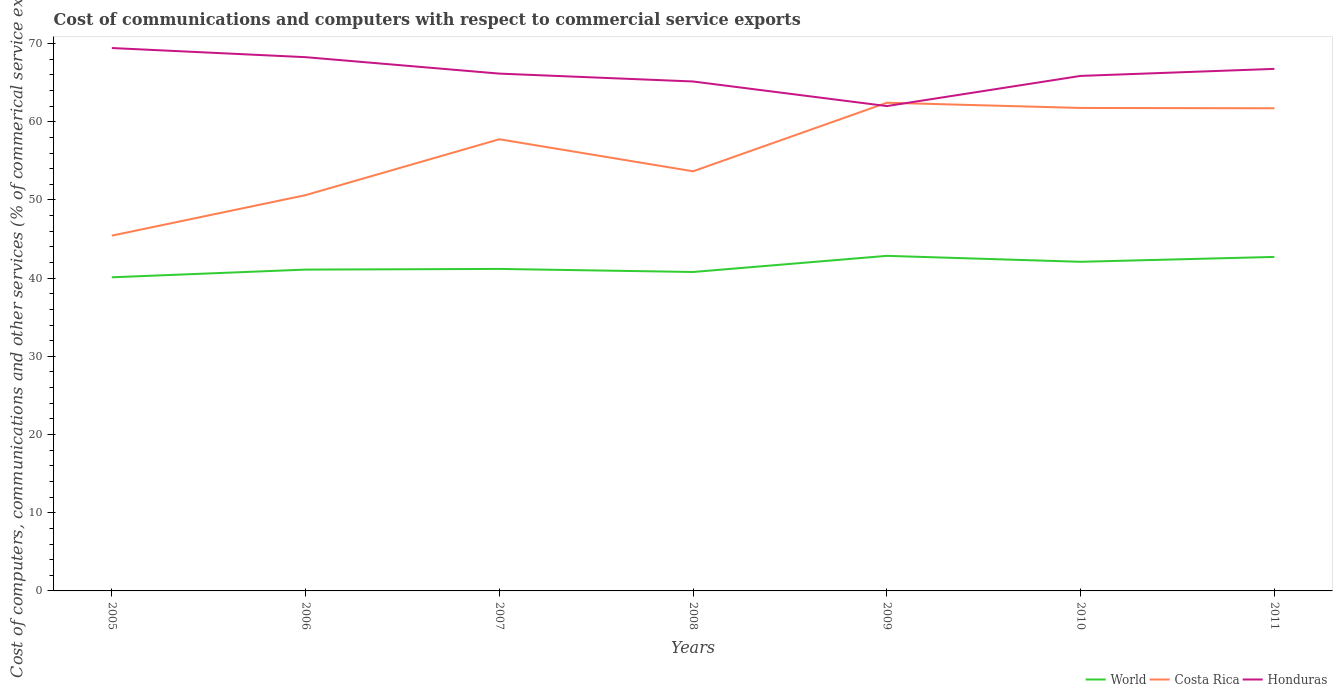Is the number of lines equal to the number of legend labels?
Offer a terse response. Yes. Across all years, what is the maximum cost of communications and computers in Costa Rica?
Keep it short and to the point. 45.44. In which year was the cost of communications and computers in Costa Rica maximum?
Provide a short and direct response. 2005. What is the total cost of communications and computers in Costa Rica in the graph?
Ensure brevity in your answer.  0.71. What is the difference between the highest and the second highest cost of communications and computers in Honduras?
Provide a succinct answer. 7.42. How many years are there in the graph?
Your answer should be very brief. 7. What is the difference between two consecutive major ticks on the Y-axis?
Provide a succinct answer. 10. Does the graph contain grids?
Provide a succinct answer. No. Where does the legend appear in the graph?
Provide a succinct answer. Bottom right. How are the legend labels stacked?
Offer a very short reply. Horizontal. What is the title of the graph?
Make the answer very short. Cost of communications and computers with respect to commercial service exports. Does "Lebanon" appear as one of the legend labels in the graph?
Your answer should be compact. No. What is the label or title of the X-axis?
Provide a succinct answer. Years. What is the label or title of the Y-axis?
Offer a very short reply. Cost of computers, communications and other services (% of commerical service exports). What is the Cost of computers, communications and other services (% of commerical service exports) in World in 2005?
Your response must be concise. 40.11. What is the Cost of computers, communications and other services (% of commerical service exports) of Costa Rica in 2005?
Offer a terse response. 45.44. What is the Cost of computers, communications and other services (% of commerical service exports) of Honduras in 2005?
Your response must be concise. 69.43. What is the Cost of computers, communications and other services (% of commerical service exports) of World in 2006?
Provide a short and direct response. 41.09. What is the Cost of computers, communications and other services (% of commerical service exports) in Costa Rica in 2006?
Your response must be concise. 50.61. What is the Cost of computers, communications and other services (% of commerical service exports) in Honduras in 2006?
Offer a terse response. 68.26. What is the Cost of computers, communications and other services (% of commerical service exports) in World in 2007?
Offer a terse response. 41.18. What is the Cost of computers, communications and other services (% of commerical service exports) of Costa Rica in 2007?
Make the answer very short. 57.76. What is the Cost of computers, communications and other services (% of commerical service exports) of Honduras in 2007?
Your answer should be compact. 66.16. What is the Cost of computers, communications and other services (% of commerical service exports) in World in 2008?
Offer a very short reply. 40.79. What is the Cost of computers, communications and other services (% of commerical service exports) of Costa Rica in 2008?
Your answer should be compact. 53.66. What is the Cost of computers, communications and other services (% of commerical service exports) in Honduras in 2008?
Your answer should be very brief. 65.15. What is the Cost of computers, communications and other services (% of commerical service exports) of World in 2009?
Offer a very short reply. 42.85. What is the Cost of computers, communications and other services (% of commerical service exports) of Costa Rica in 2009?
Provide a succinct answer. 62.43. What is the Cost of computers, communications and other services (% of commerical service exports) of Honduras in 2009?
Offer a terse response. 62. What is the Cost of computers, communications and other services (% of commerical service exports) of World in 2010?
Your answer should be compact. 42.09. What is the Cost of computers, communications and other services (% of commerical service exports) in Costa Rica in 2010?
Offer a terse response. 61.76. What is the Cost of computers, communications and other services (% of commerical service exports) of Honduras in 2010?
Your answer should be very brief. 65.86. What is the Cost of computers, communications and other services (% of commerical service exports) of World in 2011?
Provide a short and direct response. 42.71. What is the Cost of computers, communications and other services (% of commerical service exports) in Costa Rica in 2011?
Your response must be concise. 61.72. What is the Cost of computers, communications and other services (% of commerical service exports) of Honduras in 2011?
Provide a short and direct response. 66.76. Across all years, what is the maximum Cost of computers, communications and other services (% of commerical service exports) of World?
Keep it short and to the point. 42.85. Across all years, what is the maximum Cost of computers, communications and other services (% of commerical service exports) of Costa Rica?
Offer a very short reply. 62.43. Across all years, what is the maximum Cost of computers, communications and other services (% of commerical service exports) in Honduras?
Provide a succinct answer. 69.43. Across all years, what is the minimum Cost of computers, communications and other services (% of commerical service exports) in World?
Your answer should be compact. 40.11. Across all years, what is the minimum Cost of computers, communications and other services (% of commerical service exports) of Costa Rica?
Offer a terse response. 45.44. Across all years, what is the minimum Cost of computers, communications and other services (% of commerical service exports) of Honduras?
Your answer should be very brief. 62. What is the total Cost of computers, communications and other services (% of commerical service exports) in World in the graph?
Keep it short and to the point. 290.82. What is the total Cost of computers, communications and other services (% of commerical service exports) of Costa Rica in the graph?
Provide a succinct answer. 393.39. What is the total Cost of computers, communications and other services (% of commerical service exports) of Honduras in the graph?
Offer a very short reply. 463.62. What is the difference between the Cost of computers, communications and other services (% of commerical service exports) in World in 2005 and that in 2006?
Your response must be concise. -0.98. What is the difference between the Cost of computers, communications and other services (% of commerical service exports) of Costa Rica in 2005 and that in 2006?
Ensure brevity in your answer.  -5.18. What is the difference between the Cost of computers, communications and other services (% of commerical service exports) in Honduras in 2005 and that in 2006?
Your answer should be very brief. 1.17. What is the difference between the Cost of computers, communications and other services (% of commerical service exports) of World in 2005 and that in 2007?
Offer a very short reply. -1.07. What is the difference between the Cost of computers, communications and other services (% of commerical service exports) in Costa Rica in 2005 and that in 2007?
Provide a succinct answer. -12.32. What is the difference between the Cost of computers, communications and other services (% of commerical service exports) in Honduras in 2005 and that in 2007?
Ensure brevity in your answer.  3.27. What is the difference between the Cost of computers, communications and other services (% of commerical service exports) of World in 2005 and that in 2008?
Your answer should be very brief. -0.68. What is the difference between the Cost of computers, communications and other services (% of commerical service exports) in Costa Rica in 2005 and that in 2008?
Make the answer very short. -8.23. What is the difference between the Cost of computers, communications and other services (% of commerical service exports) in Honduras in 2005 and that in 2008?
Your answer should be compact. 4.28. What is the difference between the Cost of computers, communications and other services (% of commerical service exports) in World in 2005 and that in 2009?
Your response must be concise. -2.74. What is the difference between the Cost of computers, communications and other services (% of commerical service exports) in Costa Rica in 2005 and that in 2009?
Your answer should be very brief. -16.99. What is the difference between the Cost of computers, communications and other services (% of commerical service exports) of Honduras in 2005 and that in 2009?
Ensure brevity in your answer.  7.42. What is the difference between the Cost of computers, communications and other services (% of commerical service exports) in World in 2005 and that in 2010?
Give a very brief answer. -1.98. What is the difference between the Cost of computers, communications and other services (% of commerical service exports) in Costa Rica in 2005 and that in 2010?
Offer a terse response. -16.33. What is the difference between the Cost of computers, communications and other services (% of commerical service exports) of Honduras in 2005 and that in 2010?
Your answer should be compact. 3.56. What is the difference between the Cost of computers, communications and other services (% of commerical service exports) in World in 2005 and that in 2011?
Provide a short and direct response. -2.61. What is the difference between the Cost of computers, communications and other services (% of commerical service exports) of Costa Rica in 2005 and that in 2011?
Give a very brief answer. -16.29. What is the difference between the Cost of computers, communications and other services (% of commerical service exports) in Honduras in 2005 and that in 2011?
Provide a succinct answer. 2.66. What is the difference between the Cost of computers, communications and other services (% of commerical service exports) in World in 2006 and that in 2007?
Ensure brevity in your answer.  -0.09. What is the difference between the Cost of computers, communications and other services (% of commerical service exports) of Costa Rica in 2006 and that in 2007?
Give a very brief answer. -7.15. What is the difference between the Cost of computers, communications and other services (% of commerical service exports) of Honduras in 2006 and that in 2007?
Provide a short and direct response. 2.1. What is the difference between the Cost of computers, communications and other services (% of commerical service exports) in World in 2006 and that in 2008?
Offer a very short reply. 0.31. What is the difference between the Cost of computers, communications and other services (% of commerical service exports) of Costa Rica in 2006 and that in 2008?
Provide a succinct answer. -3.05. What is the difference between the Cost of computers, communications and other services (% of commerical service exports) of Honduras in 2006 and that in 2008?
Provide a succinct answer. 3.11. What is the difference between the Cost of computers, communications and other services (% of commerical service exports) of World in 2006 and that in 2009?
Your answer should be very brief. -1.76. What is the difference between the Cost of computers, communications and other services (% of commerical service exports) of Costa Rica in 2006 and that in 2009?
Offer a very short reply. -11.82. What is the difference between the Cost of computers, communications and other services (% of commerical service exports) of Honduras in 2006 and that in 2009?
Give a very brief answer. 6.25. What is the difference between the Cost of computers, communications and other services (% of commerical service exports) of World in 2006 and that in 2010?
Make the answer very short. -1. What is the difference between the Cost of computers, communications and other services (% of commerical service exports) in Costa Rica in 2006 and that in 2010?
Give a very brief answer. -11.15. What is the difference between the Cost of computers, communications and other services (% of commerical service exports) in Honduras in 2006 and that in 2010?
Ensure brevity in your answer.  2.4. What is the difference between the Cost of computers, communications and other services (% of commerical service exports) in World in 2006 and that in 2011?
Offer a terse response. -1.62. What is the difference between the Cost of computers, communications and other services (% of commerical service exports) in Costa Rica in 2006 and that in 2011?
Keep it short and to the point. -11.11. What is the difference between the Cost of computers, communications and other services (% of commerical service exports) of Honduras in 2006 and that in 2011?
Ensure brevity in your answer.  1.5. What is the difference between the Cost of computers, communications and other services (% of commerical service exports) in World in 2007 and that in 2008?
Your answer should be very brief. 0.39. What is the difference between the Cost of computers, communications and other services (% of commerical service exports) in Costa Rica in 2007 and that in 2008?
Your answer should be compact. 4.1. What is the difference between the Cost of computers, communications and other services (% of commerical service exports) of World in 2007 and that in 2009?
Offer a terse response. -1.67. What is the difference between the Cost of computers, communications and other services (% of commerical service exports) of Costa Rica in 2007 and that in 2009?
Provide a short and direct response. -4.67. What is the difference between the Cost of computers, communications and other services (% of commerical service exports) in Honduras in 2007 and that in 2009?
Make the answer very short. 4.15. What is the difference between the Cost of computers, communications and other services (% of commerical service exports) in World in 2007 and that in 2010?
Provide a succinct answer. -0.91. What is the difference between the Cost of computers, communications and other services (% of commerical service exports) of Costa Rica in 2007 and that in 2010?
Your answer should be compact. -4. What is the difference between the Cost of computers, communications and other services (% of commerical service exports) of Honduras in 2007 and that in 2010?
Ensure brevity in your answer.  0.29. What is the difference between the Cost of computers, communications and other services (% of commerical service exports) of World in 2007 and that in 2011?
Your answer should be very brief. -1.54. What is the difference between the Cost of computers, communications and other services (% of commerical service exports) in Costa Rica in 2007 and that in 2011?
Provide a short and direct response. -3.96. What is the difference between the Cost of computers, communications and other services (% of commerical service exports) in Honduras in 2007 and that in 2011?
Your answer should be very brief. -0.61. What is the difference between the Cost of computers, communications and other services (% of commerical service exports) in World in 2008 and that in 2009?
Make the answer very short. -2.06. What is the difference between the Cost of computers, communications and other services (% of commerical service exports) in Costa Rica in 2008 and that in 2009?
Ensure brevity in your answer.  -8.77. What is the difference between the Cost of computers, communications and other services (% of commerical service exports) of Honduras in 2008 and that in 2009?
Offer a very short reply. 3.14. What is the difference between the Cost of computers, communications and other services (% of commerical service exports) of World in 2008 and that in 2010?
Provide a short and direct response. -1.3. What is the difference between the Cost of computers, communications and other services (% of commerical service exports) in Costa Rica in 2008 and that in 2010?
Make the answer very short. -8.1. What is the difference between the Cost of computers, communications and other services (% of commerical service exports) of Honduras in 2008 and that in 2010?
Provide a short and direct response. -0.71. What is the difference between the Cost of computers, communications and other services (% of commerical service exports) of World in 2008 and that in 2011?
Your answer should be compact. -1.93. What is the difference between the Cost of computers, communications and other services (% of commerical service exports) in Costa Rica in 2008 and that in 2011?
Provide a short and direct response. -8.06. What is the difference between the Cost of computers, communications and other services (% of commerical service exports) in Honduras in 2008 and that in 2011?
Your response must be concise. -1.61. What is the difference between the Cost of computers, communications and other services (% of commerical service exports) of World in 2009 and that in 2010?
Offer a terse response. 0.76. What is the difference between the Cost of computers, communications and other services (% of commerical service exports) in Costa Rica in 2009 and that in 2010?
Keep it short and to the point. 0.67. What is the difference between the Cost of computers, communications and other services (% of commerical service exports) of Honduras in 2009 and that in 2010?
Keep it short and to the point. -3.86. What is the difference between the Cost of computers, communications and other services (% of commerical service exports) of World in 2009 and that in 2011?
Give a very brief answer. 0.14. What is the difference between the Cost of computers, communications and other services (% of commerical service exports) in Costa Rica in 2009 and that in 2011?
Your answer should be compact. 0.71. What is the difference between the Cost of computers, communications and other services (% of commerical service exports) in Honduras in 2009 and that in 2011?
Make the answer very short. -4.76. What is the difference between the Cost of computers, communications and other services (% of commerical service exports) of World in 2010 and that in 2011?
Provide a short and direct response. -0.62. What is the difference between the Cost of computers, communications and other services (% of commerical service exports) of Costa Rica in 2010 and that in 2011?
Provide a short and direct response. 0.04. What is the difference between the Cost of computers, communications and other services (% of commerical service exports) in Honduras in 2010 and that in 2011?
Ensure brevity in your answer.  -0.9. What is the difference between the Cost of computers, communications and other services (% of commerical service exports) in World in 2005 and the Cost of computers, communications and other services (% of commerical service exports) in Costa Rica in 2006?
Your response must be concise. -10.51. What is the difference between the Cost of computers, communications and other services (% of commerical service exports) in World in 2005 and the Cost of computers, communications and other services (% of commerical service exports) in Honduras in 2006?
Ensure brevity in your answer.  -28.15. What is the difference between the Cost of computers, communications and other services (% of commerical service exports) of Costa Rica in 2005 and the Cost of computers, communications and other services (% of commerical service exports) of Honduras in 2006?
Offer a terse response. -22.82. What is the difference between the Cost of computers, communications and other services (% of commerical service exports) in World in 2005 and the Cost of computers, communications and other services (% of commerical service exports) in Costa Rica in 2007?
Offer a terse response. -17.65. What is the difference between the Cost of computers, communications and other services (% of commerical service exports) in World in 2005 and the Cost of computers, communications and other services (% of commerical service exports) in Honduras in 2007?
Give a very brief answer. -26.05. What is the difference between the Cost of computers, communications and other services (% of commerical service exports) in Costa Rica in 2005 and the Cost of computers, communications and other services (% of commerical service exports) in Honduras in 2007?
Provide a short and direct response. -20.72. What is the difference between the Cost of computers, communications and other services (% of commerical service exports) in World in 2005 and the Cost of computers, communications and other services (% of commerical service exports) in Costa Rica in 2008?
Your response must be concise. -13.56. What is the difference between the Cost of computers, communications and other services (% of commerical service exports) in World in 2005 and the Cost of computers, communications and other services (% of commerical service exports) in Honduras in 2008?
Make the answer very short. -25.04. What is the difference between the Cost of computers, communications and other services (% of commerical service exports) of Costa Rica in 2005 and the Cost of computers, communications and other services (% of commerical service exports) of Honduras in 2008?
Your response must be concise. -19.71. What is the difference between the Cost of computers, communications and other services (% of commerical service exports) of World in 2005 and the Cost of computers, communications and other services (% of commerical service exports) of Costa Rica in 2009?
Offer a very short reply. -22.32. What is the difference between the Cost of computers, communications and other services (% of commerical service exports) in World in 2005 and the Cost of computers, communications and other services (% of commerical service exports) in Honduras in 2009?
Your answer should be very brief. -21.9. What is the difference between the Cost of computers, communications and other services (% of commerical service exports) in Costa Rica in 2005 and the Cost of computers, communications and other services (% of commerical service exports) in Honduras in 2009?
Offer a very short reply. -16.57. What is the difference between the Cost of computers, communications and other services (% of commerical service exports) in World in 2005 and the Cost of computers, communications and other services (% of commerical service exports) in Costa Rica in 2010?
Your answer should be very brief. -21.66. What is the difference between the Cost of computers, communications and other services (% of commerical service exports) of World in 2005 and the Cost of computers, communications and other services (% of commerical service exports) of Honduras in 2010?
Ensure brevity in your answer.  -25.75. What is the difference between the Cost of computers, communications and other services (% of commerical service exports) in Costa Rica in 2005 and the Cost of computers, communications and other services (% of commerical service exports) in Honduras in 2010?
Your answer should be compact. -20.43. What is the difference between the Cost of computers, communications and other services (% of commerical service exports) of World in 2005 and the Cost of computers, communications and other services (% of commerical service exports) of Costa Rica in 2011?
Make the answer very short. -21.61. What is the difference between the Cost of computers, communications and other services (% of commerical service exports) in World in 2005 and the Cost of computers, communications and other services (% of commerical service exports) in Honduras in 2011?
Make the answer very short. -26.65. What is the difference between the Cost of computers, communications and other services (% of commerical service exports) of Costa Rica in 2005 and the Cost of computers, communications and other services (% of commerical service exports) of Honduras in 2011?
Ensure brevity in your answer.  -21.33. What is the difference between the Cost of computers, communications and other services (% of commerical service exports) of World in 2006 and the Cost of computers, communications and other services (% of commerical service exports) of Costa Rica in 2007?
Give a very brief answer. -16.67. What is the difference between the Cost of computers, communications and other services (% of commerical service exports) of World in 2006 and the Cost of computers, communications and other services (% of commerical service exports) of Honduras in 2007?
Your response must be concise. -25.06. What is the difference between the Cost of computers, communications and other services (% of commerical service exports) in Costa Rica in 2006 and the Cost of computers, communications and other services (% of commerical service exports) in Honduras in 2007?
Provide a short and direct response. -15.54. What is the difference between the Cost of computers, communications and other services (% of commerical service exports) of World in 2006 and the Cost of computers, communications and other services (% of commerical service exports) of Costa Rica in 2008?
Your answer should be compact. -12.57. What is the difference between the Cost of computers, communications and other services (% of commerical service exports) of World in 2006 and the Cost of computers, communications and other services (% of commerical service exports) of Honduras in 2008?
Your answer should be very brief. -24.06. What is the difference between the Cost of computers, communications and other services (% of commerical service exports) in Costa Rica in 2006 and the Cost of computers, communications and other services (% of commerical service exports) in Honduras in 2008?
Ensure brevity in your answer.  -14.53. What is the difference between the Cost of computers, communications and other services (% of commerical service exports) in World in 2006 and the Cost of computers, communications and other services (% of commerical service exports) in Costa Rica in 2009?
Provide a succinct answer. -21.34. What is the difference between the Cost of computers, communications and other services (% of commerical service exports) of World in 2006 and the Cost of computers, communications and other services (% of commerical service exports) of Honduras in 2009?
Offer a terse response. -20.91. What is the difference between the Cost of computers, communications and other services (% of commerical service exports) of Costa Rica in 2006 and the Cost of computers, communications and other services (% of commerical service exports) of Honduras in 2009?
Offer a terse response. -11.39. What is the difference between the Cost of computers, communications and other services (% of commerical service exports) in World in 2006 and the Cost of computers, communications and other services (% of commerical service exports) in Costa Rica in 2010?
Offer a very short reply. -20.67. What is the difference between the Cost of computers, communications and other services (% of commerical service exports) in World in 2006 and the Cost of computers, communications and other services (% of commerical service exports) in Honduras in 2010?
Ensure brevity in your answer.  -24.77. What is the difference between the Cost of computers, communications and other services (% of commerical service exports) in Costa Rica in 2006 and the Cost of computers, communications and other services (% of commerical service exports) in Honduras in 2010?
Your response must be concise. -15.25. What is the difference between the Cost of computers, communications and other services (% of commerical service exports) of World in 2006 and the Cost of computers, communications and other services (% of commerical service exports) of Costa Rica in 2011?
Provide a short and direct response. -20.63. What is the difference between the Cost of computers, communications and other services (% of commerical service exports) of World in 2006 and the Cost of computers, communications and other services (% of commerical service exports) of Honduras in 2011?
Ensure brevity in your answer.  -25.67. What is the difference between the Cost of computers, communications and other services (% of commerical service exports) of Costa Rica in 2006 and the Cost of computers, communications and other services (% of commerical service exports) of Honduras in 2011?
Your answer should be very brief. -16.15. What is the difference between the Cost of computers, communications and other services (% of commerical service exports) in World in 2007 and the Cost of computers, communications and other services (% of commerical service exports) in Costa Rica in 2008?
Keep it short and to the point. -12.49. What is the difference between the Cost of computers, communications and other services (% of commerical service exports) of World in 2007 and the Cost of computers, communications and other services (% of commerical service exports) of Honduras in 2008?
Offer a terse response. -23.97. What is the difference between the Cost of computers, communications and other services (% of commerical service exports) in Costa Rica in 2007 and the Cost of computers, communications and other services (% of commerical service exports) in Honduras in 2008?
Your answer should be compact. -7.39. What is the difference between the Cost of computers, communications and other services (% of commerical service exports) in World in 2007 and the Cost of computers, communications and other services (% of commerical service exports) in Costa Rica in 2009?
Offer a very short reply. -21.25. What is the difference between the Cost of computers, communications and other services (% of commerical service exports) in World in 2007 and the Cost of computers, communications and other services (% of commerical service exports) in Honduras in 2009?
Make the answer very short. -20.83. What is the difference between the Cost of computers, communications and other services (% of commerical service exports) in Costa Rica in 2007 and the Cost of computers, communications and other services (% of commerical service exports) in Honduras in 2009?
Give a very brief answer. -4.24. What is the difference between the Cost of computers, communications and other services (% of commerical service exports) in World in 2007 and the Cost of computers, communications and other services (% of commerical service exports) in Costa Rica in 2010?
Your answer should be compact. -20.59. What is the difference between the Cost of computers, communications and other services (% of commerical service exports) of World in 2007 and the Cost of computers, communications and other services (% of commerical service exports) of Honduras in 2010?
Give a very brief answer. -24.68. What is the difference between the Cost of computers, communications and other services (% of commerical service exports) in Costa Rica in 2007 and the Cost of computers, communications and other services (% of commerical service exports) in Honduras in 2010?
Ensure brevity in your answer.  -8.1. What is the difference between the Cost of computers, communications and other services (% of commerical service exports) in World in 2007 and the Cost of computers, communications and other services (% of commerical service exports) in Costa Rica in 2011?
Provide a short and direct response. -20.54. What is the difference between the Cost of computers, communications and other services (% of commerical service exports) of World in 2007 and the Cost of computers, communications and other services (% of commerical service exports) of Honduras in 2011?
Offer a very short reply. -25.58. What is the difference between the Cost of computers, communications and other services (% of commerical service exports) in Costa Rica in 2007 and the Cost of computers, communications and other services (% of commerical service exports) in Honduras in 2011?
Give a very brief answer. -9. What is the difference between the Cost of computers, communications and other services (% of commerical service exports) in World in 2008 and the Cost of computers, communications and other services (% of commerical service exports) in Costa Rica in 2009?
Keep it short and to the point. -21.64. What is the difference between the Cost of computers, communications and other services (% of commerical service exports) of World in 2008 and the Cost of computers, communications and other services (% of commerical service exports) of Honduras in 2009?
Your answer should be compact. -21.22. What is the difference between the Cost of computers, communications and other services (% of commerical service exports) of Costa Rica in 2008 and the Cost of computers, communications and other services (% of commerical service exports) of Honduras in 2009?
Offer a terse response. -8.34. What is the difference between the Cost of computers, communications and other services (% of commerical service exports) of World in 2008 and the Cost of computers, communications and other services (% of commerical service exports) of Costa Rica in 2010?
Your response must be concise. -20.98. What is the difference between the Cost of computers, communications and other services (% of commerical service exports) of World in 2008 and the Cost of computers, communications and other services (% of commerical service exports) of Honduras in 2010?
Provide a succinct answer. -25.08. What is the difference between the Cost of computers, communications and other services (% of commerical service exports) in Costa Rica in 2008 and the Cost of computers, communications and other services (% of commerical service exports) in Honduras in 2010?
Ensure brevity in your answer.  -12.2. What is the difference between the Cost of computers, communications and other services (% of commerical service exports) in World in 2008 and the Cost of computers, communications and other services (% of commerical service exports) in Costa Rica in 2011?
Provide a short and direct response. -20.93. What is the difference between the Cost of computers, communications and other services (% of commerical service exports) in World in 2008 and the Cost of computers, communications and other services (% of commerical service exports) in Honduras in 2011?
Provide a succinct answer. -25.98. What is the difference between the Cost of computers, communications and other services (% of commerical service exports) in Costa Rica in 2008 and the Cost of computers, communications and other services (% of commerical service exports) in Honduras in 2011?
Your answer should be compact. -13.1. What is the difference between the Cost of computers, communications and other services (% of commerical service exports) in World in 2009 and the Cost of computers, communications and other services (% of commerical service exports) in Costa Rica in 2010?
Give a very brief answer. -18.91. What is the difference between the Cost of computers, communications and other services (% of commerical service exports) in World in 2009 and the Cost of computers, communications and other services (% of commerical service exports) in Honduras in 2010?
Keep it short and to the point. -23.01. What is the difference between the Cost of computers, communications and other services (% of commerical service exports) in Costa Rica in 2009 and the Cost of computers, communications and other services (% of commerical service exports) in Honduras in 2010?
Make the answer very short. -3.43. What is the difference between the Cost of computers, communications and other services (% of commerical service exports) in World in 2009 and the Cost of computers, communications and other services (% of commerical service exports) in Costa Rica in 2011?
Provide a succinct answer. -18.87. What is the difference between the Cost of computers, communications and other services (% of commerical service exports) in World in 2009 and the Cost of computers, communications and other services (% of commerical service exports) in Honduras in 2011?
Provide a succinct answer. -23.91. What is the difference between the Cost of computers, communications and other services (% of commerical service exports) of Costa Rica in 2009 and the Cost of computers, communications and other services (% of commerical service exports) of Honduras in 2011?
Your response must be concise. -4.33. What is the difference between the Cost of computers, communications and other services (% of commerical service exports) in World in 2010 and the Cost of computers, communications and other services (% of commerical service exports) in Costa Rica in 2011?
Your response must be concise. -19.63. What is the difference between the Cost of computers, communications and other services (% of commerical service exports) in World in 2010 and the Cost of computers, communications and other services (% of commerical service exports) in Honduras in 2011?
Keep it short and to the point. -24.67. What is the difference between the Cost of computers, communications and other services (% of commerical service exports) of Costa Rica in 2010 and the Cost of computers, communications and other services (% of commerical service exports) of Honduras in 2011?
Your answer should be compact. -5. What is the average Cost of computers, communications and other services (% of commerical service exports) in World per year?
Ensure brevity in your answer.  41.55. What is the average Cost of computers, communications and other services (% of commerical service exports) in Costa Rica per year?
Provide a succinct answer. 56.2. What is the average Cost of computers, communications and other services (% of commerical service exports) in Honduras per year?
Provide a short and direct response. 66.23. In the year 2005, what is the difference between the Cost of computers, communications and other services (% of commerical service exports) of World and Cost of computers, communications and other services (% of commerical service exports) of Costa Rica?
Your answer should be compact. -5.33. In the year 2005, what is the difference between the Cost of computers, communications and other services (% of commerical service exports) in World and Cost of computers, communications and other services (% of commerical service exports) in Honduras?
Give a very brief answer. -29.32. In the year 2005, what is the difference between the Cost of computers, communications and other services (% of commerical service exports) of Costa Rica and Cost of computers, communications and other services (% of commerical service exports) of Honduras?
Offer a terse response. -23.99. In the year 2006, what is the difference between the Cost of computers, communications and other services (% of commerical service exports) of World and Cost of computers, communications and other services (% of commerical service exports) of Costa Rica?
Ensure brevity in your answer.  -9.52. In the year 2006, what is the difference between the Cost of computers, communications and other services (% of commerical service exports) in World and Cost of computers, communications and other services (% of commerical service exports) in Honduras?
Ensure brevity in your answer.  -27.17. In the year 2006, what is the difference between the Cost of computers, communications and other services (% of commerical service exports) in Costa Rica and Cost of computers, communications and other services (% of commerical service exports) in Honduras?
Your answer should be compact. -17.64. In the year 2007, what is the difference between the Cost of computers, communications and other services (% of commerical service exports) in World and Cost of computers, communications and other services (% of commerical service exports) in Costa Rica?
Offer a terse response. -16.58. In the year 2007, what is the difference between the Cost of computers, communications and other services (% of commerical service exports) of World and Cost of computers, communications and other services (% of commerical service exports) of Honduras?
Your answer should be very brief. -24.98. In the year 2007, what is the difference between the Cost of computers, communications and other services (% of commerical service exports) of Costa Rica and Cost of computers, communications and other services (% of commerical service exports) of Honduras?
Your response must be concise. -8.4. In the year 2008, what is the difference between the Cost of computers, communications and other services (% of commerical service exports) of World and Cost of computers, communications and other services (% of commerical service exports) of Costa Rica?
Your answer should be very brief. -12.88. In the year 2008, what is the difference between the Cost of computers, communications and other services (% of commerical service exports) of World and Cost of computers, communications and other services (% of commerical service exports) of Honduras?
Make the answer very short. -24.36. In the year 2008, what is the difference between the Cost of computers, communications and other services (% of commerical service exports) in Costa Rica and Cost of computers, communications and other services (% of commerical service exports) in Honduras?
Your answer should be compact. -11.48. In the year 2009, what is the difference between the Cost of computers, communications and other services (% of commerical service exports) in World and Cost of computers, communications and other services (% of commerical service exports) in Costa Rica?
Make the answer very short. -19.58. In the year 2009, what is the difference between the Cost of computers, communications and other services (% of commerical service exports) in World and Cost of computers, communications and other services (% of commerical service exports) in Honduras?
Provide a succinct answer. -19.15. In the year 2009, what is the difference between the Cost of computers, communications and other services (% of commerical service exports) of Costa Rica and Cost of computers, communications and other services (% of commerical service exports) of Honduras?
Ensure brevity in your answer.  0.43. In the year 2010, what is the difference between the Cost of computers, communications and other services (% of commerical service exports) of World and Cost of computers, communications and other services (% of commerical service exports) of Costa Rica?
Your answer should be very brief. -19.67. In the year 2010, what is the difference between the Cost of computers, communications and other services (% of commerical service exports) of World and Cost of computers, communications and other services (% of commerical service exports) of Honduras?
Provide a short and direct response. -23.77. In the year 2010, what is the difference between the Cost of computers, communications and other services (% of commerical service exports) in Costa Rica and Cost of computers, communications and other services (% of commerical service exports) in Honduras?
Keep it short and to the point. -4.1. In the year 2011, what is the difference between the Cost of computers, communications and other services (% of commerical service exports) of World and Cost of computers, communications and other services (% of commerical service exports) of Costa Rica?
Your answer should be compact. -19.01. In the year 2011, what is the difference between the Cost of computers, communications and other services (% of commerical service exports) of World and Cost of computers, communications and other services (% of commerical service exports) of Honduras?
Offer a terse response. -24.05. In the year 2011, what is the difference between the Cost of computers, communications and other services (% of commerical service exports) of Costa Rica and Cost of computers, communications and other services (% of commerical service exports) of Honduras?
Give a very brief answer. -5.04. What is the ratio of the Cost of computers, communications and other services (% of commerical service exports) of World in 2005 to that in 2006?
Provide a succinct answer. 0.98. What is the ratio of the Cost of computers, communications and other services (% of commerical service exports) of Costa Rica in 2005 to that in 2006?
Offer a very short reply. 0.9. What is the ratio of the Cost of computers, communications and other services (% of commerical service exports) in Honduras in 2005 to that in 2006?
Make the answer very short. 1.02. What is the ratio of the Cost of computers, communications and other services (% of commerical service exports) in Costa Rica in 2005 to that in 2007?
Your response must be concise. 0.79. What is the ratio of the Cost of computers, communications and other services (% of commerical service exports) in Honduras in 2005 to that in 2007?
Provide a short and direct response. 1.05. What is the ratio of the Cost of computers, communications and other services (% of commerical service exports) of World in 2005 to that in 2008?
Provide a succinct answer. 0.98. What is the ratio of the Cost of computers, communications and other services (% of commerical service exports) in Costa Rica in 2005 to that in 2008?
Offer a very short reply. 0.85. What is the ratio of the Cost of computers, communications and other services (% of commerical service exports) of Honduras in 2005 to that in 2008?
Your response must be concise. 1.07. What is the ratio of the Cost of computers, communications and other services (% of commerical service exports) of World in 2005 to that in 2009?
Your answer should be very brief. 0.94. What is the ratio of the Cost of computers, communications and other services (% of commerical service exports) of Costa Rica in 2005 to that in 2009?
Provide a short and direct response. 0.73. What is the ratio of the Cost of computers, communications and other services (% of commerical service exports) of Honduras in 2005 to that in 2009?
Ensure brevity in your answer.  1.12. What is the ratio of the Cost of computers, communications and other services (% of commerical service exports) of World in 2005 to that in 2010?
Offer a very short reply. 0.95. What is the ratio of the Cost of computers, communications and other services (% of commerical service exports) of Costa Rica in 2005 to that in 2010?
Give a very brief answer. 0.74. What is the ratio of the Cost of computers, communications and other services (% of commerical service exports) in Honduras in 2005 to that in 2010?
Give a very brief answer. 1.05. What is the ratio of the Cost of computers, communications and other services (% of commerical service exports) in World in 2005 to that in 2011?
Provide a succinct answer. 0.94. What is the ratio of the Cost of computers, communications and other services (% of commerical service exports) of Costa Rica in 2005 to that in 2011?
Provide a succinct answer. 0.74. What is the ratio of the Cost of computers, communications and other services (% of commerical service exports) of Honduras in 2005 to that in 2011?
Ensure brevity in your answer.  1.04. What is the ratio of the Cost of computers, communications and other services (% of commerical service exports) of Costa Rica in 2006 to that in 2007?
Provide a succinct answer. 0.88. What is the ratio of the Cost of computers, communications and other services (% of commerical service exports) of Honduras in 2006 to that in 2007?
Your answer should be compact. 1.03. What is the ratio of the Cost of computers, communications and other services (% of commerical service exports) of World in 2006 to that in 2008?
Offer a terse response. 1.01. What is the ratio of the Cost of computers, communications and other services (% of commerical service exports) in Costa Rica in 2006 to that in 2008?
Your answer should be very brief. 0.94. What is the ratio of the Cost of computers, communications and other services (% of commerical service exports) in Honduras in 2006 to that in 2008?
Make the answer very short. 1.05. What is the ratio of the Cost of computers, communications and other services (% of commerical service exports) in World in 2006 to that in 2009?
Offer a terse response. 0.96. What is the ratio of the Cost of computers, communications and other services (% of commerical service exports) in Costa Rica in 2006 to that in 2009?
Offer a terse response. 0.81. What is the ratio of the Cost of computers, communications and other services (% of commerical service exports) of Honduras in 2006 to that in 2009?
Provide a short and direct response. 1.1. What is the ratio of the Cost of computers, communications and other services (% of commerical service exports) in World in 2006 to that in 2010?
Offer a very short reply. 0.98. What is the ratio of the Cost of computers, communications and other services (% of commerical service exports) in Costa Rica in 2006 to that in 2010?
Offer a very short reply. 0.82. What is the ratio of the Cost of computers, communications and other services (% of commerical service exports) of Honduras in 2006 to that in 2010?
Your answer should be compact. 1.04. What is the ratio of the Cost of computers, communications and other services (% of commerical service exports) in World in 2006 to that in 2011?
Your answer should be very brief. 0.96. What is the ratio of the Cost of computers, communications and other services (% of commerical service exports) in Costa Rica in 2006 to that in 2011?
Provide a short and direct response. 0.82. What is the ratio of the Cost of computers, communications and other services (% of commerical service exports) of Honduras in 2006 to that in 2011?
Give a very brief answer. 1.02. What is the ratio of the Cost of computers, communications and other services (% of commerical service exports) in World in 2007 to that in 2008?
Keep it short and to the point. 1.01. What is the ratio of the Cost of computers, communications and other services (% of commerical service exports) in Costa Rica in 2007 to that in 2008?
Provide a succinct answer. 1.08. What is the ratio of the Cost of computers, communications and other services (% of commerical service exports) of Honduras in 2007 to that in 2008?
Provide a short and direct response. 1.02. What is the ratio of the Cost of computers, communications and other services (% of commerical service exports) in Costa Rica in 2007 to that in 2009?
Provide a succinct answer. 0.93. What is the ratio of the Cost of computers, communications and other services (% of commerical service exports) in Honduras in 2007 to that in 2009?
Your answer should be compact. 1.07. What is the ratio of the Cost of computers, communications and other services (% of commerical service exports) of World in 2007 to that in 2010?
Offer a very short reply. 0.98. What is the ratio of the Cost of computers, communications and other services (% of commerical service exports) in Costa Rica in 2007 to that in 2010?
Ensure brevity in your answer.  0.94. What is the ratio of the Cost of computers, communications and other services (% of commerical service exports) in World in 2007 to that in 2011?
Ensure brevity in your answer.  0.96. What is the ratio of the Cost of computers, communications and other services (% of commerical service exports) in Costa Rica in 2007 to that in 2011?
Provide a succinct answer. 0.94. What is the ratio of the Cost of computers, communications and other services (% of commerical service exports) in Honduras in 2007 to that in 2011?
Provide a succinct answer. 0.99. What is the ratio of the Cost of computers, communications and other services (% of commerical service exports) in World in 2008 to that in 2009?
Provide a short and direct response. 0.95. What is the ratio of the Cost of computers, communications and other services (% of commerical service exports) of Costa Rica in 2008 to that in 2009?
Offer a terse response. 0.86. What is the ratio of the Cost of computers, communications and other services (% of commerical service exports) in Honduras in 2008 to that in 2009?
Provide a short and direct response. 1.05. What is the ratio of the Cost of computers, communications and other services (% of commerical service exports) of Costa Rica in 2008 to that in 2010?
Provide a succinct answer. 0.87. What is the ratio of the Cost of computers, communications and other services (% of commerical service exports) in World in 2008 to that in 2011?
Make the answer very short. 0.95. What is the ratio of the Cost of computers, communications and other services (% of commerical service exports) of Costa Rica in 2008 to that in 2011?
Provide a succinct answer. 0.87. What is the ratio of the Cost of computers, communications and other services (% of commerical service exports) of Honduras in 2008 to that in 2011?
Make the answer very short. 0.98. What is the ratio of the Cost of computers, communications and other services (% of commerical service exports) of World in 2009 to that in 2010?
Make the answer very short. 1.02. What is the ratio of the Cost of computers, communications and other services (% of commerical service exports) in Costa Rica in 2009 to that in 2010?
Keep it short and to the point. 1.01. What is the ratio of the Cost of computers, communications and other services (% of commerical service exports) of Honduras in 2009 to that in 2010?
Make the answer very short. 0.94. What is the ratio of the Cost of computers, communications and other services (% of commerical service exports) in Costa Rica in 2009 to that in 2011?
Your response must be concise. 1.01. What is the ratio of the Cost of computers, communications and other services (% of commerical service exports) of Honduras in 2009 to that in 2011?
Provide a succinct answer. 0.93. What is the ratio of the Cost of computers, communications and other services (% of commerical service exports) in World in 2010 to that in 2011?
Your answer should be very brief. 0.99. What is the ratio of the Cost of computers, communications and other services (% of commerical service exports) in Honduras in 2010 to that in 2011?
Offer a terse response. 0.99. What is the difference between the highest and the second highest Cost of computers, communications and other services (% of commerical service exports) in World?
Give a very brief answer. 0.14. What is the difference between the highest and the second highest Cost of computers, communications and other services (% of commerical service exports) in Costa Rica?
Ensure brevity in your answer.  0.67. What is the difference between the highest and the second highest Cost of computers, communications and other services (% of commerical service exports) of Honduras?
Offer a very short reply. 1.17. What is the difference between the highest and the lowest Cost of computers, communications and other services (% of commerical service exports) of World?
Your answer should be very brief. 2.74. What is the difference between the highest and the lowest Cost of computers, communications and other services (% of commerical service exports) of Costa Rica?
Offer a very short reply. 16.99. What is the difference between the highest and the lowest Cost of computers, communications and other services (% of commerical service exports) in Honduras?
Make the answer very short. 7.42. 